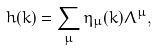Convert formula to latex. <formula><loc_0><loc_0><loc_500><loc_500>h ( { k } ) = \sum _ { \mu } \eta _ { \mu } ( { k } ) \Lambda ^ { \mu } ,</formula> 